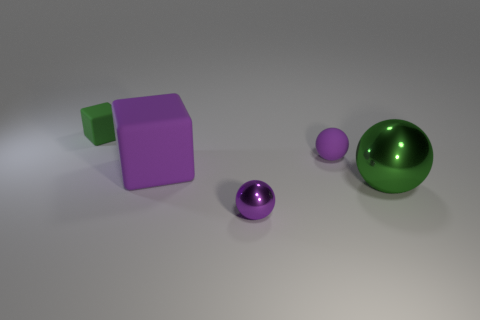There is a tiny rubber object that is the same color as the tiny shiny thing; what shape is it?
Provide a succinct answer. Sphere. Does the green sphere have the same size as the green block?
Offer a very short reply. No. There is a tiny green thing that is on the left side of the small matte object that is in front of the green matte thing; what is it made of?
Your answer should be compact. Rubber. There is a green object in front of the small green matte thing; is it the same shape as the tiny green matte object that is left of the big purple object?
Your answer should be very brief. No. Is the number of small metallic balls that are behind the big matte thing the same as the number of small green rubber things?
Ensure brevity in your answer.  No. There is a small ball in front of the big metal thing; is there a purple shiny thing that is on the left side of it?
Ensure brevity in your answer.  No. Is there any other thing of the same color as the large rubber object?
Your answer should be compact. Yes. Is the material of the purple thing right of the tiny purple metallic ball the same as the tiny cube?
Make the answer very short. Yes. Are there an equal number of big spheres that are right of the big green sphere and big green spheres behind the tiny matte block?
Ensure brevity in your answer.  Yes. There is a shiny thing on the right side of the small matte thing that is in front of the small green cube; what size is it?
Your answer should be compact. Large. 